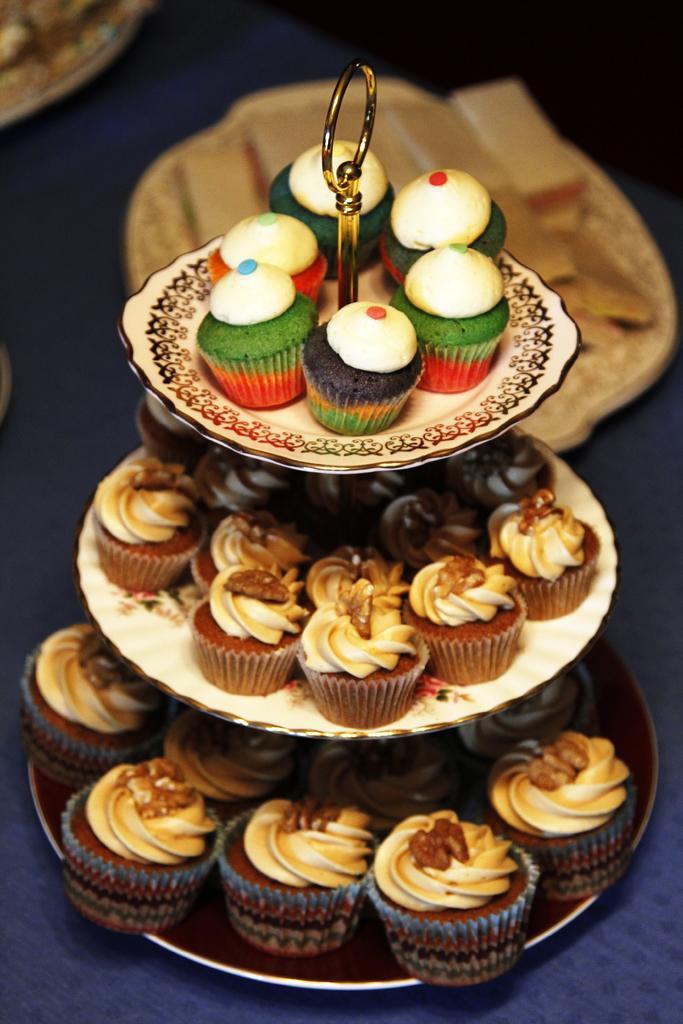Describe this image in one or two sentences. This picture shows few muffins on the cake stand on the table. 